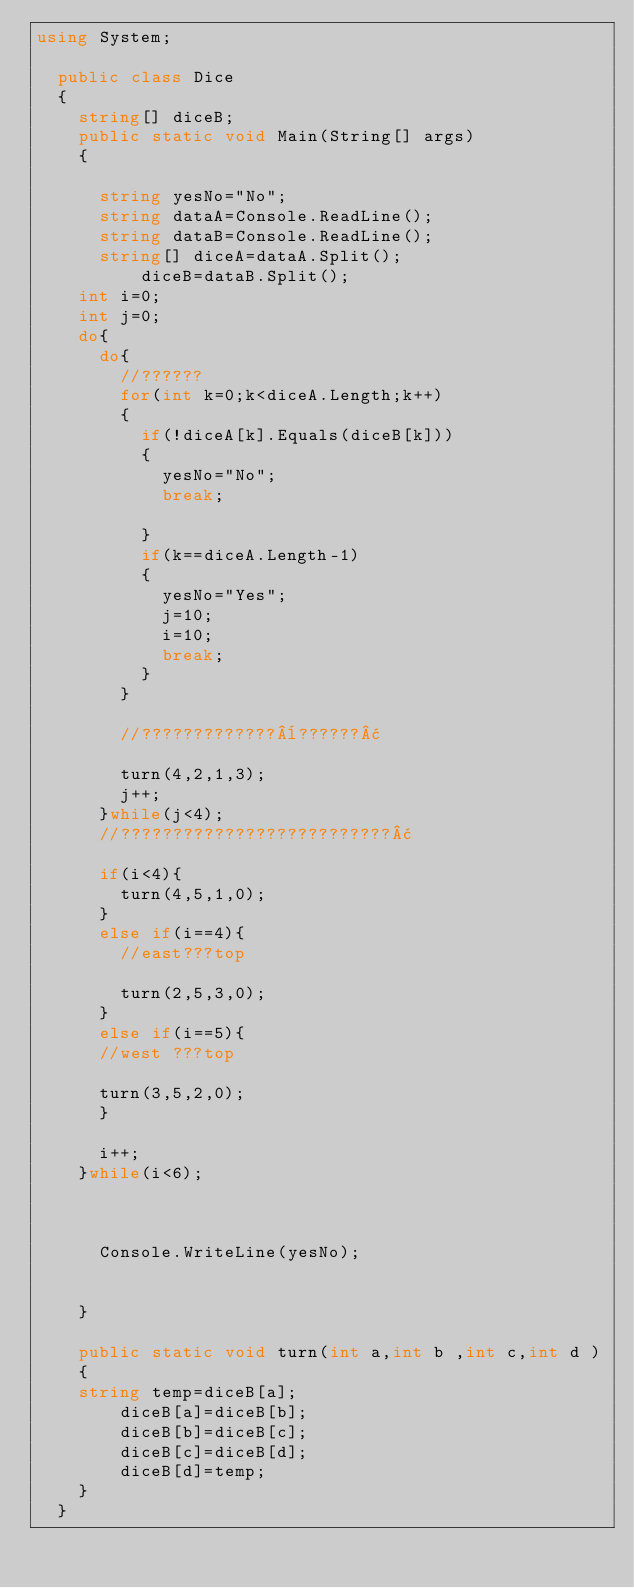Convert code to text. <code><loc_0><loc_0><loc_500><loc_500><_C#_>using System;

	public class Dice
	{
		string[] diceB;
		public static void Main(String[] args)
		{
			
			string yesNo="No";
			string dataA=Console.ReadLine();
			string dataB=Console.ReadLine();
			string[] diceA=dataA.Split();
					diceB=dataB.Split();
		int i=0;
		int j=0;
		do{
			do{
				//??????
				for(int k=0;k<diceA.Length;k++)
				{
					if(!diceA[k].Equals(diceB[k]))
					{
						yesNo="No";
						break;
					
					}
					if(k==diceA.Length-1)
					{
						yesNo="Yes";
						j=10;
						i=10;
						break;
					}
				}
				
				//?????????????¨??????¢
		
				turn(4,2,1,3);
				j++;
			}while(j<4);
			//??????????????????????????¢
			
			if(i<4){
				turn(4,5,1,0);
			}
			else if(i==4){
				//east???top
				
				turn(2,5,3,0);
			}
			else if(i==5){
			//west ???top
		
			turn(3,5,2,0);
			}
			
			i++;
		}while(i<6);
		
			  
			
			Console.WriteLine(yesNo);
					
			
		}
		
		public static void turn(int a,int b ,int c,int d )
		{
		string temp=diceB[a];
				diceB[a]=diceB[b];
				diceB[b]=diceB[c];
				diceB[c]=diceB[d];
				diceB[d]=temp;
		}
	}</code> 